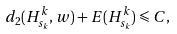<formula> <loc_0><loc_0><loc_500><loc_500>d _ { 2 } ( H ^ { k } _ { s _ { k } } , w ) + E ( H ^ { k } _ { s _ { k } } ) \leqslant C ,</formula> 